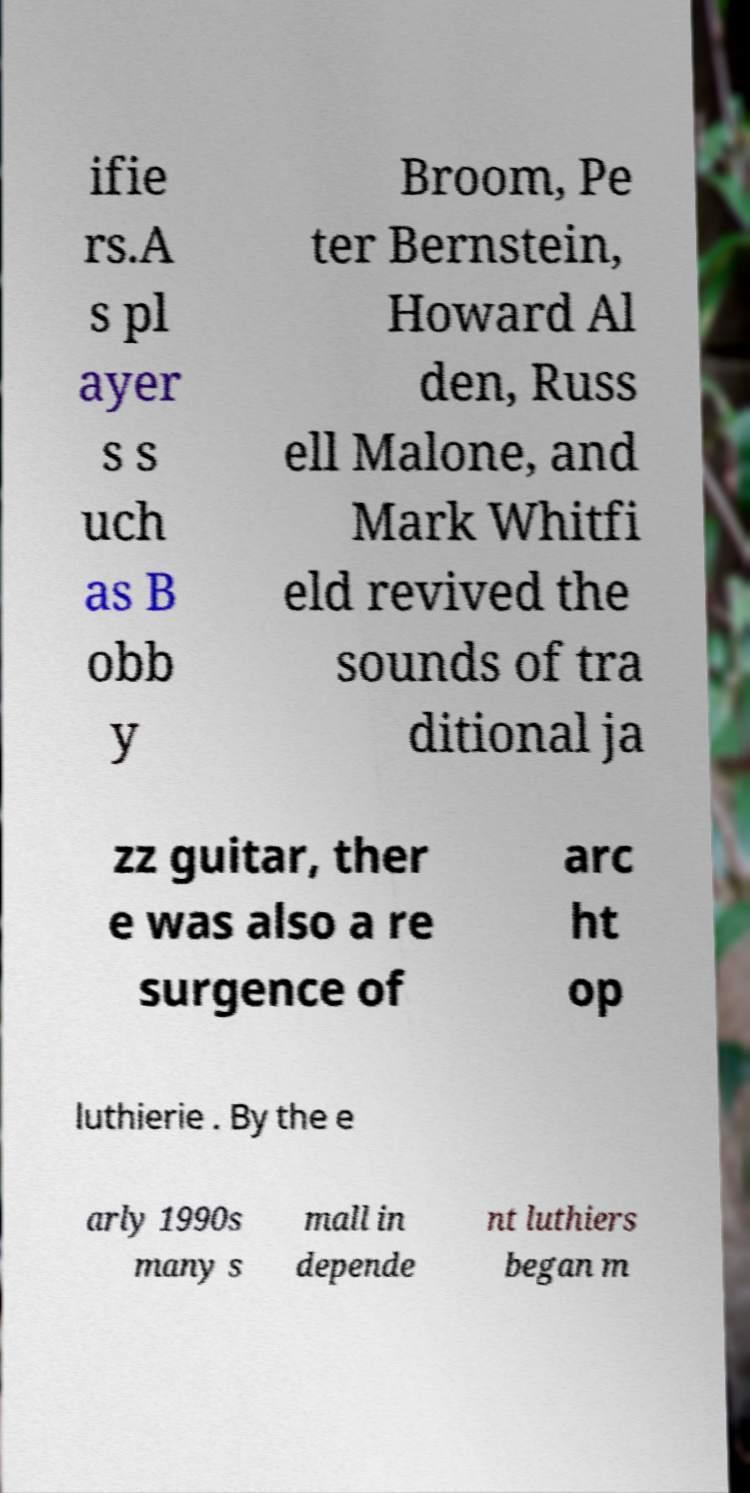Could you extract and type out the text from this image? ifie rs.A s pl ayer s s uch as B obb y Broom, Pe ter Bernstein, Howard Al den, Russ ell Malone, and Mark Whitfi eld revived the sounds of tra ditional ja zz guitar, ther e was also a re surgence of arc ht op luthierie . By the e arly 1990s many s mall in depende nt luthiers began m 